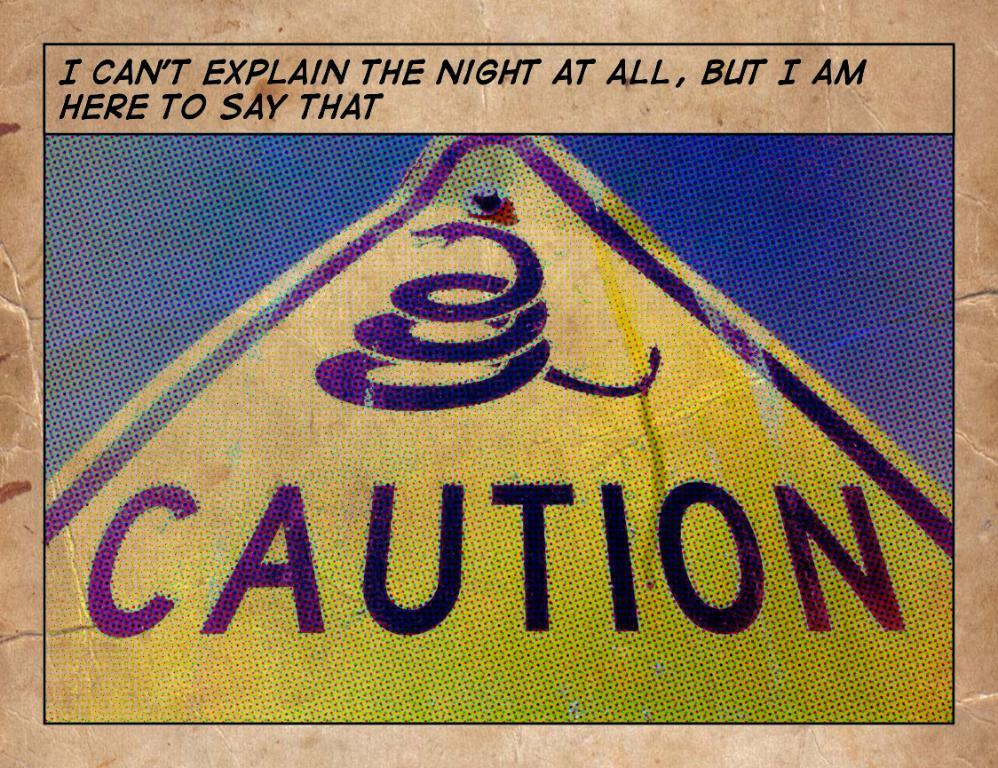<image>
Offer a succinct explanation of the picture presented. On a yellow sign, a coiling snake is depicted over the word Caution. 